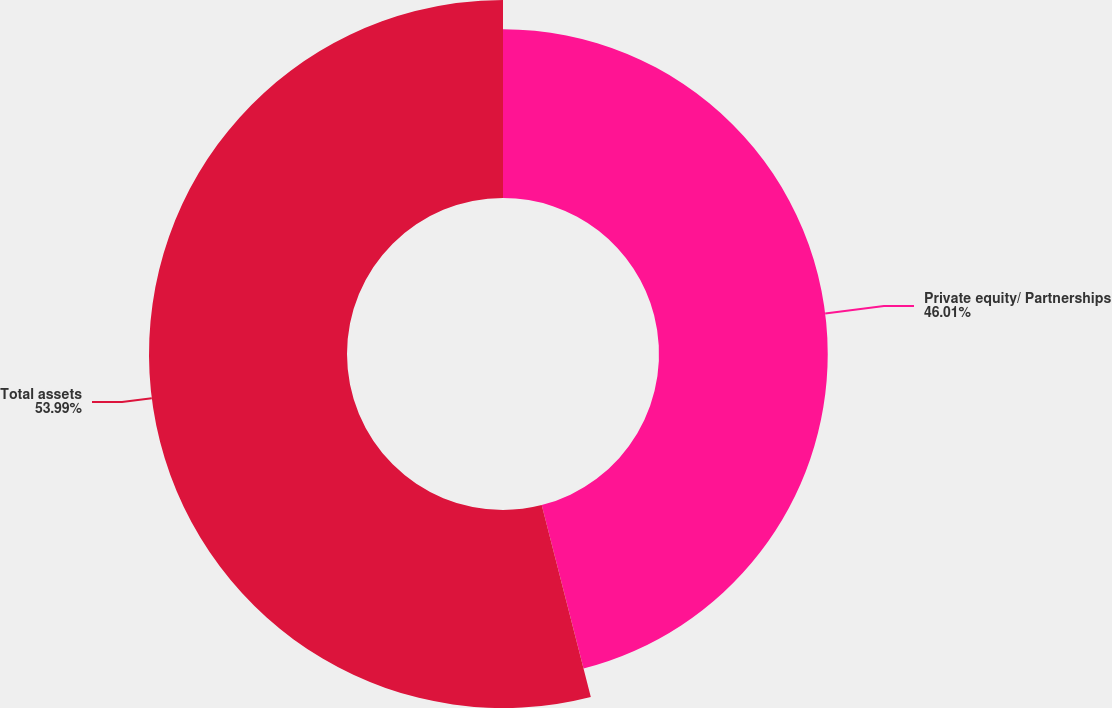Convert chart. <chart><loc_0><loc_0><loc_500><loc_500><pie_chart><fcel>Private equity/ Partnerships<fcel>Total assets<nl><fcel>46.01%<fcel>53.99%<nl></chart> 